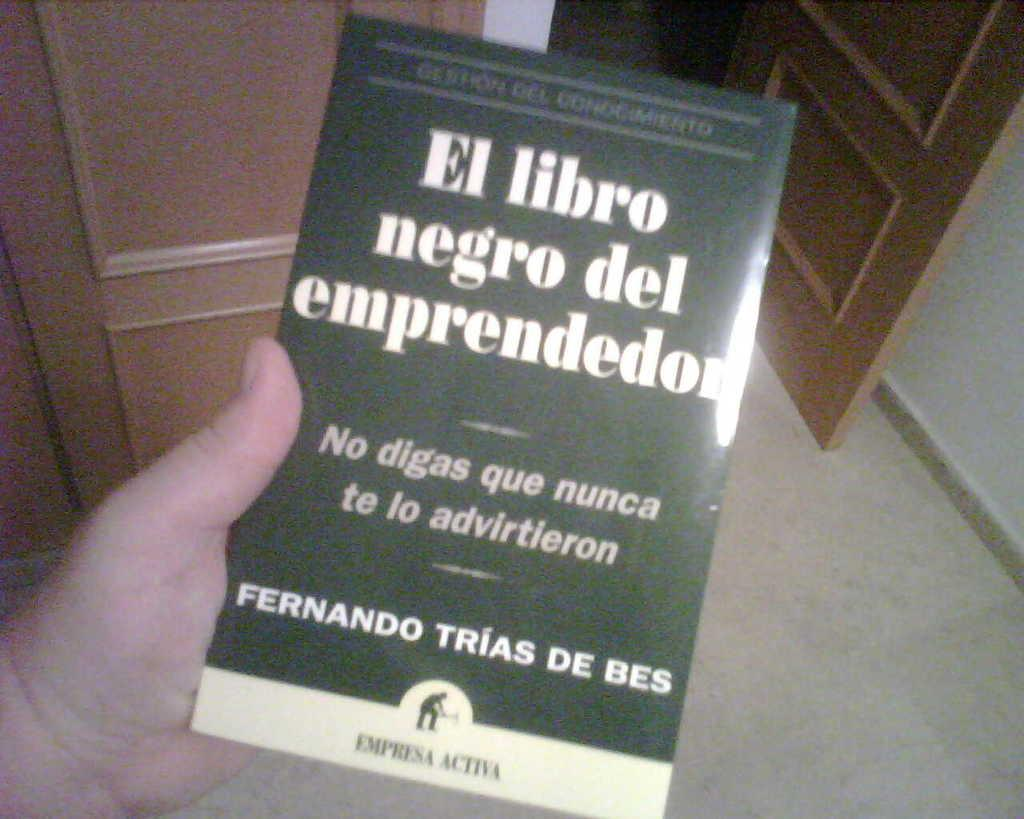What is the person's hand holding in the image? There is a person's hand holding a book in the image. What type of doors can be seen in the image? There are wooden doors in the image. What part of the room is visible in the image? The floor is visible in the image. What is one of the walls made of in the image? There is a wall in the image. What type of sugar is being used to organize the letters in the image? There is no sugar or letters present in the image. 